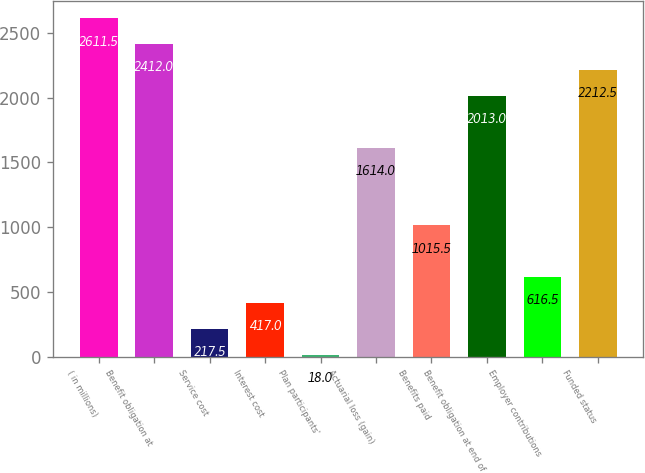<chart> <loc_0><loc_0><loc_500><loc_500><bar_chart><fcel>( in millions)<fcel>Benefit obligation at<fcel>Service cost<fcel>Interest cost<fcel>Plan participants'<fcel>Actuarial loss (gain)<fcel>Benefits paid<fcel>Benefit obligation at end of<fcel>Employer contributions<fcel>Funded status<nl><fcel>2611.5<fcel>2412<fcel>217.5<fcel>417<fcel>18<fcel>1614<fcel>1015.5<fcel>2013<fcel>616.5<fcel>2212.5<nl></chart> 